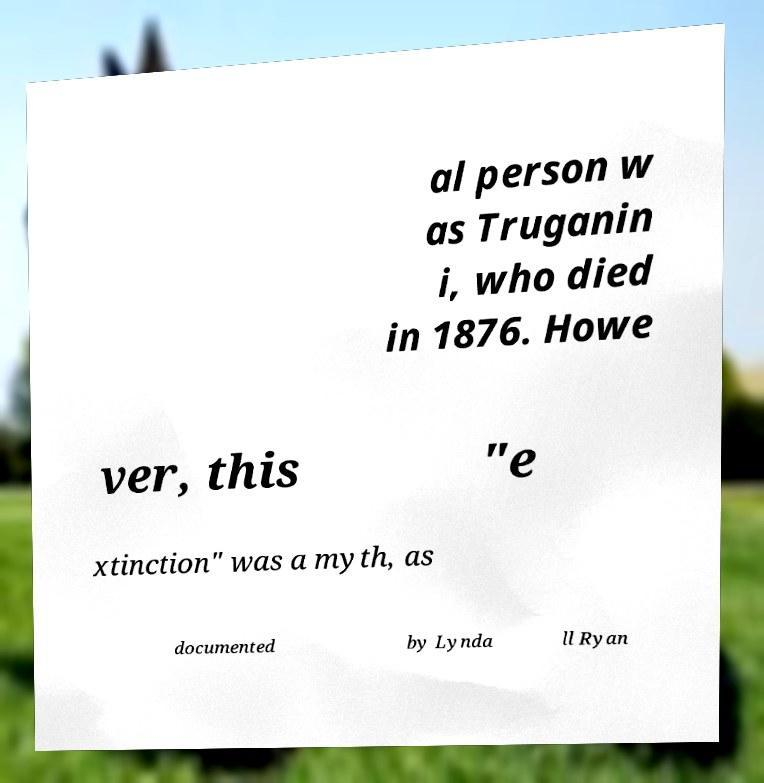Can you accurately transcribe the text from the provided image for me? al person w as Truganin i, who died in 1876. Howe ver, this "e xtinction" was a myth, as documented by Lynda ll Ryan 